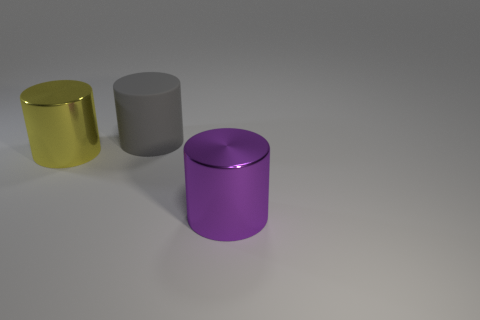Add 1 small purple matte spheres. How many objects exist? 4 Add 2 yellow metal cylinders. How many yellow metal cylinders exist? 3 Subtract 0 purple blocks. How many objects are left? 3 Subtract all gray rubber cylinders. Subtract all big gray metallic spheres. How many objects are left? 2 Add 3 yellow cylinders. How many yellow cylinders are left? 4 